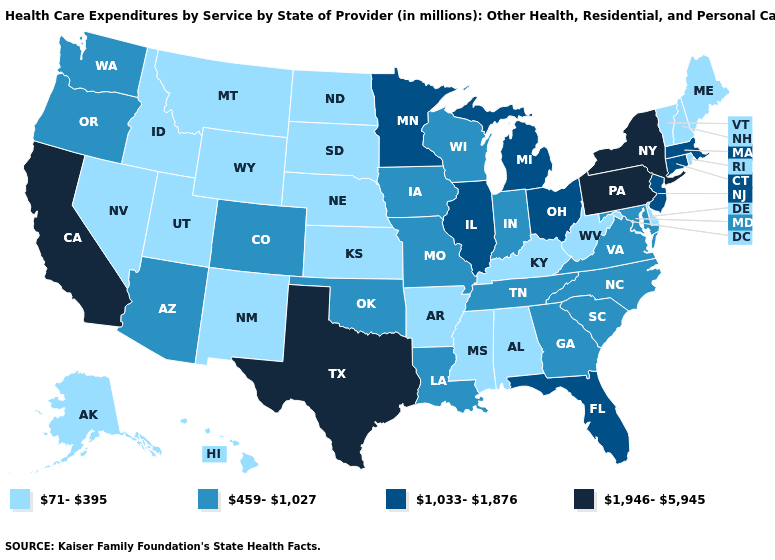What is the value of Hawaii?
Answer briefly. 71-395. Name the states that have a value in the range 459-1,027?
Answer briefly. Arizona, Colorado, Georgia, Indiana, Iowa, Louisiana, Maryland, Missouri, North Carolina, Oklahoma, Oregon, South Carolina, Tennessee, Virginia, Washington, Wisconsin. Which states have the highest value in the USA?
Give a very brief answer. California, New York, Pennsylvania, Texas. Which states have the lowest value in the MidWest?
Quick response, please. Kansas, Nebraska, North Dakota, South Dakota. Name the states that have a value in the range 71-395?
Be succinct. Alabama, Alaska, Arkansas, Delaware, Hawaii, Idaho, Kansas, Kentucky, Maine, Mississippi, Montana, Nebraska, Nevada, New Hampshire, New Mexico, North Dakota, Rhode Island, South Dakota, Utah, Vermont, West Virginia, Wyoming. Does Wyoming have a lower value than Nebraska?
Keep it brief. No. Name the states that have a value in the range 1,033-1,876?
Give a very brief answer. Connecticut, Florida, Illinois, Massachusetts, Michigan, Minnesota, New Jersey, Ohio. What is the highest value in the West ?
Write a very short answer. 1,946-5,945. How many symbols are there in the legend?
Give a very brief answer. 4. Which states have the lowest value in the Northeast?
Write a very short answer. Maine, New Hampshire, Rhode Island, Vermont. Which states hav the highest value in the West?
Give a very brief answer. California. What is the lowest value in states that border Nevada?
Answer briefly. 71-395. What is the value of Florida?
Answer briefly. 1,033-1,876. How many symbols are there in the legend?
Answer briefly. 4. 